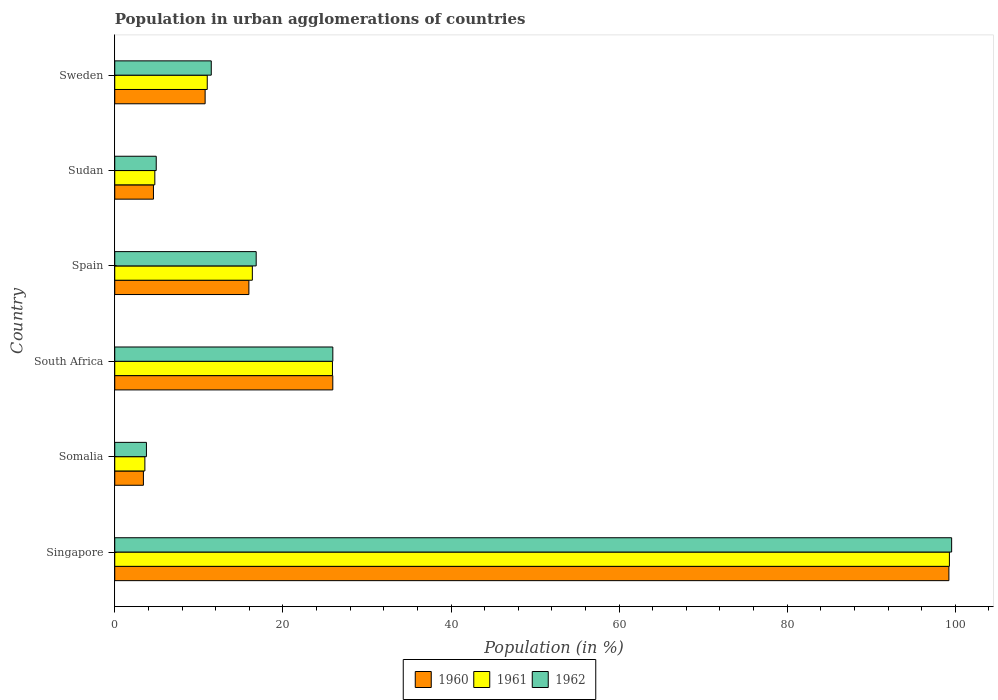How many different coloured bars are there?
Your answer should be very brief. 3. How many groups of bars are there?
Keep it short and to the point. 6. Are the number of bars on each tick of the Y-axis equal?
Keep it short and to the point. Yes. What is the label of the 6th group of bars from the top?
Your answer should be very brief. Singapore. In how many cases, is the number of bars for a given country not equal to the number of legend labels?
Ensure brevity in your answer.  0. What is the percentage of population in urban agglomerations in 1961 in Sudan?
Give a very brief answer. 4.77. Across all countries, what is the maximum percentage of population in urban agglomerations in 1960?
Offer a terse response. 99.23. Across all countries, what is the minimum percentage of population in urban agglomerations in 1962?
Offer a very short reply. 3.77. In which country was the percentage of population in urban agglomerations in 1961 maximum?
Give a very brief answer. Singapore. In which country was the percentage of population in urban agglomerations in 1962 minimum?
Provide a short and direct response. Somalia. What is the total percentage of population in urban agglomerations in 1961 in the graph?
Provide a short and direct response. 160.91. What is the difference between the percentage of population in urban agglomerations in 1961 in Singapore and that in Sudan?
Your answer should be compact. 94.53. What is the difference between the percentage of population in urban agglomerations in 1962 in Spain and the percentage of population in urban agglomerations in 1961 in Sweden?
Your answer should be compact. 5.82. What is the average percentage of population in urban agglomerations in 1961 per country?
Ensure brevity in your answer.  26.82. What is the difference between the percentage of population in urban agglomerations in 1960 and percentage of population in urban agglomerations in 1961 in South Africa?
Make the answer very short. 0.04. What is the ratio of the percentage of population in urban agglomerations in 1962 in Somalia to that in Spain?
Make the answer very short. 0.22. Is the difference between the percentage of population in urban agglomerations in 1960 in Somalia and Sudan greater than the difference between the percentage of population in urban agglomerations in 1961 in Somalia and Sudan?
Make the answer very short. No. What is the difference between the highest and the second highest percentage of population in urban agglomerations in 1962?
Provide a succinct answer. 73.62. What is the difference between the highest and the lowest percentage of population in urban agglomerations in 1962?
Provide a succinct answer. 95.79. Is the sum of the percentage of population in urban agglomerations in 1962 in Sudan and Sweden greater than the maximum percentage of population in urban agglomerations in 1960 across all countries?
Ensure brevity in your answer.  No. Are all the bars in the graph horizontal?
Your answer should be compact. Yes. How many countries are there in the graph?
Offer a very short reply. 6. Does the graph contain grids?
Ensure brevity in your answer.  No. Where does the legend appear in the graph?
Ensure brevity in your answer.  Bottom center. How many legend labels are there?
Offer a very short reply. 3. How are the legend labels stacked?
Give a very brief answer. Horizontal. What is the title of the graph?
Your answer should be compact. Population in urban agglomerations of countries. Does "1988" appear as one of the legend labels in the graph?
Your response must be concise. No. What is the label or title of the X-axis?
Provide a succinct answer. Population (in %). What is the Population (in %) in 1960 in Singapore?
Give a very brief answer. 99.23. What is the Population (in %) of 1961 in Singapore?
Provide a succinct answer. 99.29. What is the Population (in %) of 1962 in Singapore?
Give a very brief answer. 99.56. What is the Population (in %) of 1960 in Somalia?
Your answer should be very brief. 3.41. What is the Population (in %) of 1961 in Somalia?
Make the answer very short. 3.58. What is the Population (in %) of 1962 in Somalia?
Give a very brief answer. 3.77. What is the Population (in %) in 1960 in South Africa?
Give a very brief answer. 25.94. What is the Population (in %) in 1961 in South Africa?
Give a very brief answer. 25.9. What is the Population (in %) of 1962 in South Africa?
Offer a terse response. 25.94. What is the Population (in %) of 1960 in Spain?
Your answer should be very brief. 15.96. What is the Population (in %) in 1961 in Spain?
Your answer should be very brief. 16.37. What is the Population (in %) in 1962 in Spain?
Make the answer very short. 16.83. What is the Population (in %) of 1960 in Sudan?
Your response must be concise. 4.6. What is the Population (in %) in 1961 in Sudan?
Keep it short and to the point. 4.77. What is the Population (in %) of 1962 in Sudan?
Keep it short and to the point. 4.93. What is the Population (in %) of 1960 in Sweden?
Provide a short and direct response. 10.75. What is the Population (in %) of 1961 in Sweden?
Make the answer very short. 11. What is the Population (in %) of 1962 in Sweden?
Provide a succinct answer. 11.48. Across all countries, what is the maximum Population (in %) of 1960?
Your response must be concise. 99.23. Across all countries, what is the maximum Population (in %) in 1961?
Your answer should be compact. 99.29. Across all countries, what is the maximum Population (in %) of 1962?
Your response must be concise. 99.56. Across all countries, what is the minimum Population (in %) of 1960?
Offer a very short reply. 3.41. Across all countries, what is the minimum Population (in %) of 1961?
Your response must be concise. 3.58. Across all countries, what is the minimum Population (in %) in 1962?
Provide a succinct answer. 3.77. What is the total Population (in %) of 1960 in the graph?
Give a very brief answer. 159.89. What is the total Population (in %) of 1961 in the graph?
Your response must be concise. 160.91. What is the total Population (in %) of 1962 in the graph?
Provide a short and direct response. 162.51. What is the difference between the Population (in %) in 1960 in Singapore and that in Somalia?
Your answer should be compact. 95.82. What is the difference between the Population (in %) of 1961 in Singapore and that in Somalia?
Ensure brevity in your answer.  95.71. What is the difference between the Population (in %) in 1962 in Singapore and that in Somalia?
Give a very brief answer. 95.79. What is the difference between the Population (in %) in 1960 in Singapore and that in South Africa?
Ensure brevity in your answer.  73.29. What is the difference between the Population (in %) in 1961 in Singapore and that in South Africa?
Your answer should be compact. 73.4. What is the difference between the Population (in %) in 1962 in Singapore and that in South Africa?
Your answer should be very brief. 73.62. What is the difference between the Population (in %) in 1960 in Singapore and that in Spain?
Offer a very short reply. 83.27. What is the difference between the Population (in %) of 1961 in Singapore and that in Spain?
Give a very brief answer. 82.92. What is the difference between the Population (in %) of 1962 in Singapore and that in Spain?
Offer a very short reply. 82.73. What is the difference between the Population (in %) of 1960 in Singapore and that in Sudan?
Your response must be concise. 94.63. What is the difference between the Population (in %) in 1961 in Singapore and that in Sudan?
Your response must be concise. 94.53. What is the difference between the Population (in %) of 1962 in Singapore and that in Sudan?
Provide a short and direct response. 94.62. What is the difference between the Population (in %) of 1960 in Singapore and that in Sweden?
Your answer should be compact. 88.48. What is the difference between the Population (in %) in 1961 in Singapore and that in Sweden?
Your response must be concise. 88.29. What is the difference between the Population (in %) of 1962 in Singapore and that in Sweden?
Give a very brief answer. 88.08. What is the difference between the Population (in %) of 1960 in Somalia and that in South Africa?
Your answer should be compact. -22.53. What is the difference between the Population (in %) in 1961 in Somalia and that in South Africa?
Keep it short and to the point. -22.31. What is the difference between the Population (in %) of 1962 in Somalia and that in South Africa?
Your response must be concise. -22.17. What is the difference between the Population (in %) in 1960 in Somalia and that in Spain?
Your answer should be compact. -12.55. What is the difference between the Population (in %) in 1961 in Somalia and that in Spain?
Offer a terse response. -12.78. What is the difference between the Population (in %) of 1962 in Somalia and that in Spain?
Give a very brief answer. -13.06. What is the difference between the Population (in %) in 1960 in Somalia and that in Sudan?
Offer a very short reply. -1.2. What is the difference between the Population (in %) in 1961 in Somalia and that in Sudan?
Ensure brevity in your answer.  -1.18. What is the difference between the Population (in %) of 1962 in Somalia and that in Sudan?
Offer a very short reply. -1.17. What is the difference between the Population (in %) of 1960 in Somalia and that in Sweden?
Give a very brief answer. -7.34. What is the difference between the Population (in %) in 1961 in Somalia and that in Sweden?
Your answer should be very brief. -7.42. What is the difference between the Population (in %) in 1962 in Somalia and that in Sweden?
Provide a short and direct response. -7.71. What is the difference between the Population (in %) in 1960 in South Africa and that in Spain?
Ensure brevity in your answer.  9.98. What is the difference between the Population (in %) in 1961 in South Africa and that in Spain?
Keep it short and to the point. 9.53. What is the difference between the Population (in %) in 1962 in South Africa and that in Spain?
Offer a very short reply. 9.12. What is the difference between the Population (in %) in 1960 in South Africa and that in Sudan?
Your response must be concise. 21.33. What is the difference between the Population (in %) of 1961 in South Africa and that in Sudan?
Offer a very short reply. 21.13. What is the difference between the Population (in %) in 1962 in South Africa and that in Sudan?
Keep it short and to the point. 21.01. What is the difference between the Population (in %) of 1960 in South Africa and that in Sweden?
Your answer should be very brief. 15.19. What is the difference between the Population (in %) of 1961 in South Africa and that in Sweden?
Offer a terse response. 14.89. What is the difference between the Population (in %) in 1962 in South Africa and that in Sweden?
Provide a succinct answer. 14.46. What is the difference between the Population (in %) in 1960 in Spain and that in Sudan?
Make the answer very short. 11.35. What is the difference between the Population (in %) of 1961 in Spain and that in Sudan?
Ensure brevity in your answer.  11.6. What is the difference between the Population (in %) of 1962 in Spain and that in Sudan?
Ensure brevity in your answer.  11.89. What is the difference between the Population (in %) of 1960 in Spain and that in Sweden?
Your response must be concise. 5.21. What is the difference between the Population (in %) of 1961 in Spain and that in Sweden?
Keep it short and to the point. 5.36. What is the difference between the Population (in %) in 1962 in Spain and that in Sweden?
Offer a very short reply. 5.34. What is the difference between the Population (in %) of 1960 in Sudan and that in Sweden?
Provide a succinct answer. -6.15. What is the difference between the Population (in %) of 1961 in Sudan and that in Sweden?
Provide a short and direct response. -6.24. What is the difference between the Population (in %) in 1962 in Sudan and that in Sweden?
Your answer should be very brief. -6.55. What is the difference between the Population (in %) in 1960 in Singapore and the Population (in %) in 1961 in Somalia?
Keep it short and to the point. 95.65. What is the difference between the Population (in %) in 1960 in Singapore and the Population (in %) in 1962 in Somalia?
Provide a short and direct response. 95.46. What is the difference between the Population (in %) in 1961 in Singapore and the Population (in %) in 1962 in Somalia?
Your response must be concise. 95.52. What is the difference between the Population (in %) in 1960 in Singapore and the Population (in %) in 1961 in South Africa?
Your answer should be very brief. 73.33. What is the difference between the Population (in %) in 1960 in Singapore and the Population (in %) in 1962 in South Africa?
Make the answer very short. 73.29. What is the difference between the Population (in %) of 1961 in Singapore and the Population (in %) of 1962 in South Africa?
Offer a terse response. 73.35. What is the difference between the Population (in %) of 1960 in Singapore and the Population (in %) of 1961 in Spain?
Offer a terse response. 82.86. What is the difference between the Population (in %) of 1960 in Singapore and the Population (in %) of 1962 in Spain?
Give a very brief answer. 82.4. What is the difference between the Population (in %) in 1961 in Singapore and the Population (in %) in 1962 in Spain?
Offer a terse response. 82.47. What is the difference between the Population (in %) in 1960 in Singapore and the Population (in %) in 1961 in Sudan?
Ensure brevity in your answer.  94.46. What is the difference between the Population (in %) of 1960 in Singapore and the Population (in %) of 1962 in Sudan?
Provide a short and direct response. 94.29. What is the difference between the Population (in %) in 1961 in Singapore and the Population (in %) in 1962 in Sudan?
Provide a succinct answer. 94.36. What is the difference between the Population (in %) of 1960 in Singapore and the Population (in %) of 1961 in Sweden?
Give a very brief answer. 88.23. What is the difference between the Population (in %) of 1960 in Singapore and the Population (in %) of 1962 in Sweden?
Your answer should be compact. 87.75. What is the difference between the Population (in %) of 1961 in Singapore and the Population (in %) of 1962 in Sweden?
Ensure brevity in your answer.  87.81. What is the difference between the Population (in %) of 1960 in Somalia and the Population (in %) of 1961 in South Africa?
Ensure brevity in your answer.  -22.49. What is the difference between the Population (in %) of 1960 in Somalia and the Population (in %) of 1962 in South Africa?
Offer a very short reply. -22.53. What is the difference between the Population (in %) in 1961 in Somalia and the Population (in %) in 1962 in South Africa?
Give a very brief answer. -22.36. What is the difference between the Population (in %) of 1960 in Somalia and the Population (in %) of 1961 in Spain?
Provide a short and direct response. -12.96. What is the difference between the Population (in %) in 1960 in Somalia and the Population (in %) in 1962 in Spain?
Give a very brief answer. -13.42. What is the difference between the Population (in %) in 1961 in Somalia and the Population (in %) in 1962 in Spain?
Give a very brief answer. -13.24. What is the difference between the Population (in %) of 1960 in Somalia and the Population (in %) of 1961 in Sudan?
Ensure brevity in your answer.  -1.36. What is the difference between the Population (in %) of 1960 in Somalia and the Population (in %) of 1962 in Sudan?
Give a very brief answer. -1.53. What is the difference between the Population (in %) of 1961 in Somalia and the Population (in %) of 1962 in Sudan?
Offer a very short reply. -1.35. What is the difference between the Population (in %) of 1960 in Somalia and the Population (in %) of 1961 in Sweden?
Your answer should be very brief. -7.6. What is the difference between the Population (in %) of 1960 in Somalia and the Population (in %) of 1962 in Sweden?
Provide a succinct answer. -8.07. What is the difference between the Population (in %) in 1961 in Somalia and the Population (in %) in 1962 in Sweden?
Your answer should be compact. -7.9. What is the difference between the Population (in %) in 1960 in South Africa and the Population (in %) in 1961 in Spain?
Provide a succinct answer. 9.57. What is the difference between the Population (in %) in 1960 in South Africa and the Population (in %) in 1962 in Spain?
Ensure brevity in your answer.  9.11. What is the difference between the Population (in %) in 1961 in South Africa and the Population (in %) in 1962 in Spain?
Provide a short and direct response. 9.07. What is the difference between the Population (in %) in 1960 in South Africa and the Population (in %) in 1961 in Sudan?
Make the answer very short. 21.17. What is the difference between the Population (in %) in 1960 in South Africa and the Population (in %) in 1962 in Sudan?
Your response must be concise. 21. What is the difference between the Population (in %) of 1961 in South Africa and the Population (in %) of 1962 in Sudan?
Give a very brief answer. 20.96. What is the difference between the Population (in %) in 1960 in South Africa and the Population (in %) in 1961 in Sweden?
Offer a terse response. 14.93. What is the difference between the Population (in %) of 1960 in South Africa and the Population (in %) of 1962 in Sweden?
Offer a terse response. 14.46. What is the difference between the Population (in %) of 1961 in South Africa and the Population (in %) of 1962 in Sweden?
Ensure brevity in your answer.  14.42. What is the difference between the Population (in %) of 1960 in Spain and the Population (in %) of 1961 in Sudan?
Your answer should be compact. 11.19. What is the difference between the Population (in %) of 1960 in Spain and the Population (in %) of 1962 in Sudan?
Provide a short and direct response. 11.02. What is the difference between the Population (in %) of 1961 in Spain and the Population (in %) of 1962 in Sudan?
Provide a succinct answer. 11.43. What is the difference between the Population (in %) of 1960 in Spain and the Population (in %) of 1961 in Sweden?
Make the answer very short. 4.95. What is the difference between the Population (in %) of 1960 in Spain and the Population (in %) of 1962 in Sweden?
Offer a very short reply. 4.47. What is the difference between the Population (in %) in 1961 in Spain and the Population (in %) in 1962 in Sweden?
Your response must be concise. 4.89. What is the difference between the Population (in %) of 1960 in Sudan and the Population (in %) of 1961 in Sweden?
Offer a terse response. -6.4. What is the difference between the Population (in %) in 1960 in Sudan and the Population (in %) in 1962 in Sweden?
Your response must be concise. -6.88. What is the difference between the Population (in %) in 1961 in Sudan and the Population (in %) in 1962 in Sweden?
Make the answer very short. -6.71. What is the average Population (in %) of 1960 per country?
Provide a short and direct response. 26.65. What is the average Population (in %) in 1961 per country?
Your response must be concise. 26.82. What is the average Population (in %) in 1962 per country?
Make the answer very short. 27.09. What is the difference between the Population (in %) of 1960 and Population (in %) of 1961 in Singapore?
Offer a terse response. -0.06. What is the difference between the Population (in %) of 1960 and Population (in %) of 1962 in Singapore?
Your response must be concise. -0.33. What is the difference between the Population (in %) of 1961 and Population (in %) of 1962 in Singapore?
Provide a short and direct response. -0.27. What is the difference between the Population (in %) in 1960 and Population (in %) in 1961 in Somalia?
Keep it short and to the point. -0.18. What is the difference between the Population (in %) of 1960 and Population (in %) of 1962 in Somalia?
Provide a short and direct response. -0.36. What is the difference between the Population (in %) in 1961 and Population (in %) in 1962 in Somalia?
Your answer should be compact. -0.19. What is the difference between the Population (in %) in 1960 and Population (in %) in 1961 in South Africa?
Give a very brief answer. 0.04. What is the difference between the Population (in %) of 1960 and Population (in %) of 1962 in South Africa?
Give a very brief answer. -0. What is the difference between the Population (in %) of 1961 and Population (in %) of 1962 in South Africa?
Provide a succinct answer. -0.04. What is the difference between the Population (in %) of 1960 and Population (in %) of 1961 in Spain?
Offer a terse response. -0.41. What is the difference between the Population (in %) in 1960 and Population (in %) in 1962 in Spain?
Keep it short and to the point. -0.87. What is the difference between the Population (in %) in 1961 and Population (in %) in 1962 in Spain?
Provide a succinct answer. -0.46. What is the difference between the Population (in %) of 1960 and Population (in %) of 1961 in Sudan?
Give a very brief answer. -0.16. What is the difference between the Population (in %) in 1960 and Population (in %) in 1962 in Sudan?
Ensure brevity in your answer.  -0.33. What is the difference between the Population (in %) of 1961 and Population (in %) of 1962 in Sudan?
Offer a terse response. -0.17. What is the difference between the Population (in %) in 1960 and Population (in %) in 1961 in Sweden?
Your answer should be very brief. -0.25. What is the difference between the Population (in %) in 1960 and Population (in %) in 1962 in Sweden?
Offer a very short reply. -0.73. What is the difference between the Population (in %) of 1961 and Population (in %) of 1962 in Sweden?
Make the answer very short. -0.48. What is the ratio of the Population (in %) of 1960 in Singapore to that in Somalia?
Your answer should be compact. 29.12. What is the ratio of the Population (in %) of 1961 in Singapore to that in Somalia?
Provide a short and direct response. 27.7. What is the ratio of the Population (in %) of 1962 in Singapore to that in Somalia?
Provide a succinct answer. 26.41. What is the ratio of the Population (in %) of 1960 in Singapore to that in South Africa?
Make the answer very short. 3.83. What is the ratio of the Population (in %) in 1961 in Singapore to that in South Africa?
Give a very brief answer. 3.83. What is the ratio of the Population (in %) of 1962 in Singapore to that in South Africa?
Provide a succinct answer. 3.84. What is the ratio of the Population (in %) of 1960 in Singapore to that in Spain?
Offer a very short reply. 6.22. What is the ratio of the Population (in %) of 1961 in Singapore to that in Spain?
Ensure brevity in your answer.  6.07. What is the ratio of the Population (in %) of 1962 in Singapore to that in Spain?
Offer a terse response. 5.92. What is the ratio of the Population (in %) in 1960 in Singapore to that in Sudan?
Your answer should be compact. 21.55. What is the ratio of the Population (in %) of 1961 in Singapore to that in Sudan?
Provide a short and direct response. 20.83. What is the ratio of the Population (in %) in 1962 in Singapore to that in Sudan?
Keep it short and to the point. 20.17. What is the ratio of the Population (in %) in 1960 in Singapore to that in Sweden?
Ensure brevity in your answer.  9.23. What is the ratio of the Population (in %) in 1961 in Singapore to that in Sweden?
Your response must be concise. 9.02. What is the ratio of the Population (in %) of 1962 in Singapore to that in Sweden?
Offer a terse response. 8.67. What is the ratio of the Population (in %) in 1960 in Somalia to that in South Africa?
Your answer should be compact. 0.13. What is the ratio of the Population (in %) of 1961 in Somalia to that in South Africa?
Make the answer very short. 0.14. What is the ratio of the Population (in %) of 1962 in Somalia to that in South Africa?
Your answer should be compact. 0.15. What is the ratio of the Population (in %) of 1960 in Somalia to that in Spain?
Provide a succinct answer. 0.21. What is the ratio of the Population (in %) in 1961 in Somalia to that in Spain?
Make the answer very short. 0.22. What is the ratio of the Population (in %) in 1962 in Somalia to that in Spain?
Ensure brevity in your answer.  0.22. What is the ratio of the Population (in %) in 1960 in Somalia to that in Sudan?
Ensure brevity in your answer.  0.74. What is the ratio of the Population (in %) of 1961 in Somalia to that in Sudan?
Your answer should be compact. 0.75. What is the ratio of the Population (in %) of 1962 in Somalia to that in Sudan?
Give a very brief answer. 0.76. What is the ratio of the Population (in %) in 1960 in Somalia to that in Sweden?
Keep it short and to the point. 0.32. What is the ratio of the Population (in %) in 1961 in Somalia to that in Sweden?
Keep it short and to the point. 0.33. What is the ratio of the Population (in %) of 1962 in Somalia to that in Sweden?
Provide a succinct answer. 0.33. What is the ratio of the Population (in %) of 1960 in South Africa to that in Spain?
Provide a succinct answer. 1.63. What is the ratio of the Population (in %) in 1961 in South Africa to that in Spain?
Your response must be concise. 1.58. What is the ratio of the Population (in %) in 1962 in South Africa to that in Spain?
Make the answer very short. 1.54. What is the ratio of the Population (in %) of 1960 in South Africa to that in Sudan?
Offer a very short reply. 5.63. What is the ratio of the Population (in %) in 1961 in South Africa to that in Sudan?
Offer a very short reply. 5.43. What is the ratio of the Population (in %) of 1962 in South Africa to that in Sudan?
Your answer should be very brief. 5.26. What is the ratio of the Population (in %) of 1960 in South Africa to that in Sweden?
Make the answer very short. 2.41. What is the ratio of the Population (in %) of 1961 in South Africa to that in Sweden?
Offer a terse response. 2.35. What is the ratio of the Population (in %) in 1962 in South Africa to that in Sweden?
Your response must be concise. 2.26. What is the ratio of the Population (in %) of 1960 in Spain to that in Sudan?
Your answer should be compact. 3.47. What is the ratio of the Population (in %) in 1961 in Spain to that in Sudan?
Offer a terse response. 3.43. What is the ratio of the Population (in %) of 1962 in Spain to that in Sudan?
Your answer should be compact. 3.41. What is the ratio of the Population (in %) of 1960 in Spain to that in Sweden?
Give a very brief answer. 1.48. What is the ratio of the Population (in %) of 1961 in Spain to that in Sweden?
Provide a short and direct response. 1.49. What is the ratio of the Population (in %) in 1962 in Spain to that in Sweden?
Give a very brief answer. 1.47. What is the ratio of the Population (in %) in 1960 in Sudan to that in Sweden?
Ensure brevity in your answer.  0.43. What is the ratio of the Population (in %) in 1961 in Sudan to that in Sweden?
Provide a succinct answer. 0.43. What is the ratio of the Population (in %) in 1962 in Sudan to that in Sweden?
Offer a very short reply. 0.43. What is the difference between the highest and the second highest Population (in %) of 1960?
Give a very brief answer. 73.29. What is the difference between the highest and the second highest Population (in %) of 1961?
Give a very brief answer. 73.4. What is the difference between the highest and the second highest Population (in %) in 1962?
Keep it short and to the point. 73.62. What is the difference between the highest and the lowest Population (in %) in 1960?
Keep it short and to the point. 95.82. What is the difference between the highest and the lowest Population (in %) of 1961?
Provide a succinct answer. 95.71. What is the difference between the highest and the lowest Population (in %) in 1962?
Offer a very short reply. 95.79. 